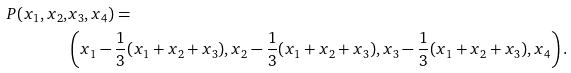Convert formula to latex. <formula><loc_0><loc_0><loc_500><loc_500>P ( x _ { 1 } , x _ { 2 } , & x _ { 3 } , x _ { 4 } ) = \\ & \left ( x _ { 1 } - \frac { 1 } { 3 } ( x _ { 1 } + x _ { 2 } + x _ { 3 } ) , x _ { 2 } - \frac { 1 } { 3 } ( x _ { 1 } + x _ { 2 } + x _ { 3 } ) , x _ { 3 } - \frac { 1 } { 3 } ( x _ { 1 } + x _ { 2 } + x _ { 3 } ) , x _ { 4 } \right ) .</formula> 